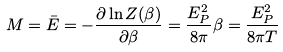Convert formula to latex. <formula><loc_0><loc_0><loc_500><loc_500>M = \bar { E } = - { \frac { \partial \ln Z ( \beta ) } { \partial \beta } } = { \frac { E _ { P } ^ { 2 } } { 8 \pi } } \beta = { \frac { E _ { P } ^ { 2 } } { 8 \pi T } }</formula> 